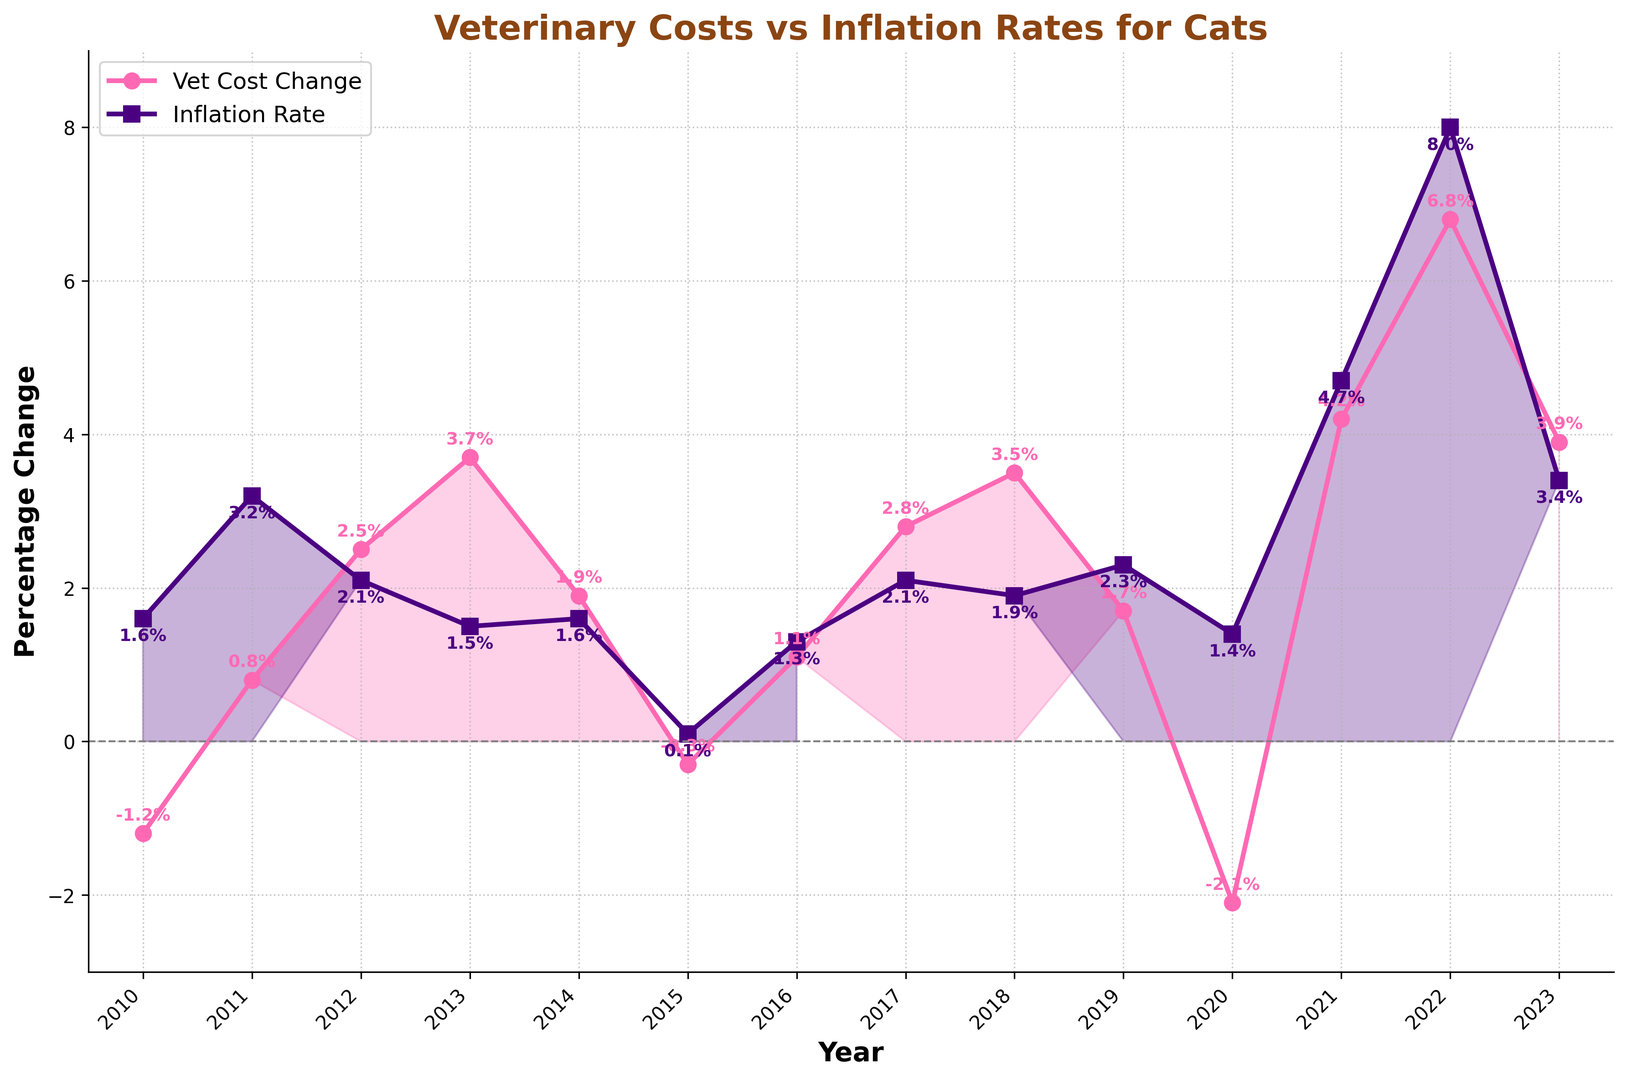Which year had the largest decrease in veterinary costs? The largest decrease in veterinary costs is represented by the highest negative value on the Vet Cost Change line. By examining the Vet Cost Change values, the year 2020 had the largest decrease at -2.1%.
Answer: 2020 Which year had the greatest increase in veterinary costs compared to the previous year? The greatest increase in veterinary costs is represented by the largest positive change on the Vet Cost Change line. From 2021 to 2022, veterinary costs increased from 4.2% to 6.8%, which is a 2.6% increase.
Answer: 2022 What is the average Vet Cost Change for the years 2022 and 2023? To find the average Vet Cost Change for the years 2022 and 2023, add the Vet Cost Change values for these years (6.8% and 3.9%) and divide by 2. (6.8 + 3.9) / 2 = 5.35
Answer: 5.35 Which years had Vet Cost Changes below the Inflation Rate? Vet Cost Changes below the Inflation Rate occur when the pink line (Vet Cost Change) is below the purple line (Inflation Rate). These years are 2011, 2020, and 2022.
Answer: 2011, 2020, 2022 Compare the Inflation Rate from 2021 to 2022. Did it increase or decrease and by how much? To find the change, subtract the 2021 Inflation Rate from the 2022 Inflation Rate. The 2021 Inflation Rate is 4.7% and the 2022 Inflation Rate is 8.0%. 8.0 - 4.7 = 3.3, so it increased by 3.3%.
Answer: Increased by 3.3% In how many years did the Vet Cost Change cross the zero line (changing from negative to positive or vice versa)? The Vet Cost Change crosses the zero line where the pink line crosses the horizontal axis. This happened three times: from 2010 to 2011, 2014 to 2015, and 2019 to 2020.
Answer: 3 Which year experienced the highest inflation rate? The year with the highest inflation rate can be identified by the highest point on the line representing the Inflation Rate. In 2022, the inflation rate was 8.0%, the highest in the dataset.
Answer: 2022 Were veterinary costs or inflation rates more variable over the years? The variability can be assessed by noticing the fluctuation magnitude of the two lines. The Vet Cost Change line shows steep and frequent ups and downs compared to the relatively steadier purple line of the Inflation Rate. So, veterinary costs were more variable.
Answer: Veterinary costs 